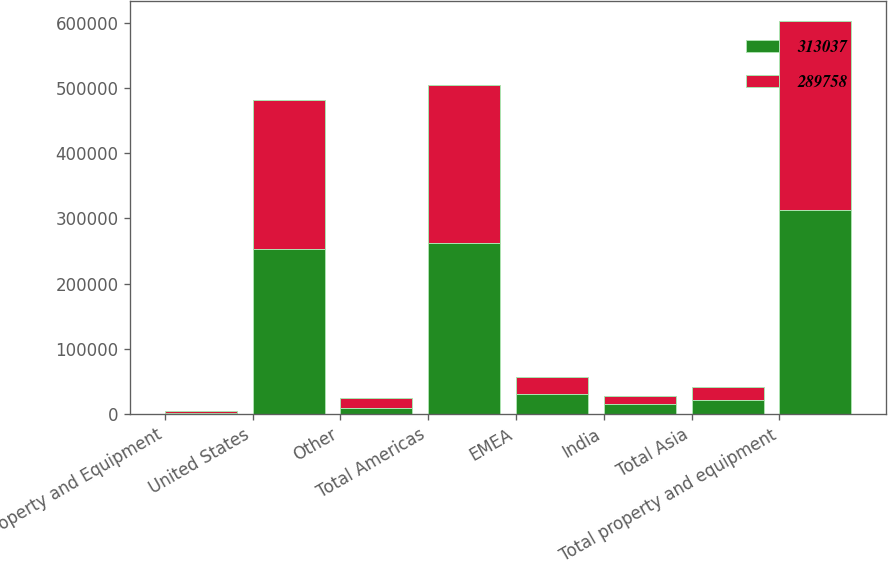Convert chart. <chart><loc_0><loc_0><loc_500><loc_500><stacked_bar_chart><ecel><fcel>Property and Equipment<fcel>United States<fcel>Other<fcel>Total Americas<fcel>EMEA<fcel>India<fcel>Total Asia<fcel>Total property and equipment<nl><fcel>313037<fcel>2008<fcel>252434<fcel>9154<fcel>261588<fcel>29887<fcel>15242<fcel>21562<fcel>313037<nl><fcel>289758<fcel>2007<fcel>228263<fcel>15364<fcel>243627<fcel>27035<fcel>11633<fcel>19096<fcel>289758<nl></chart> 